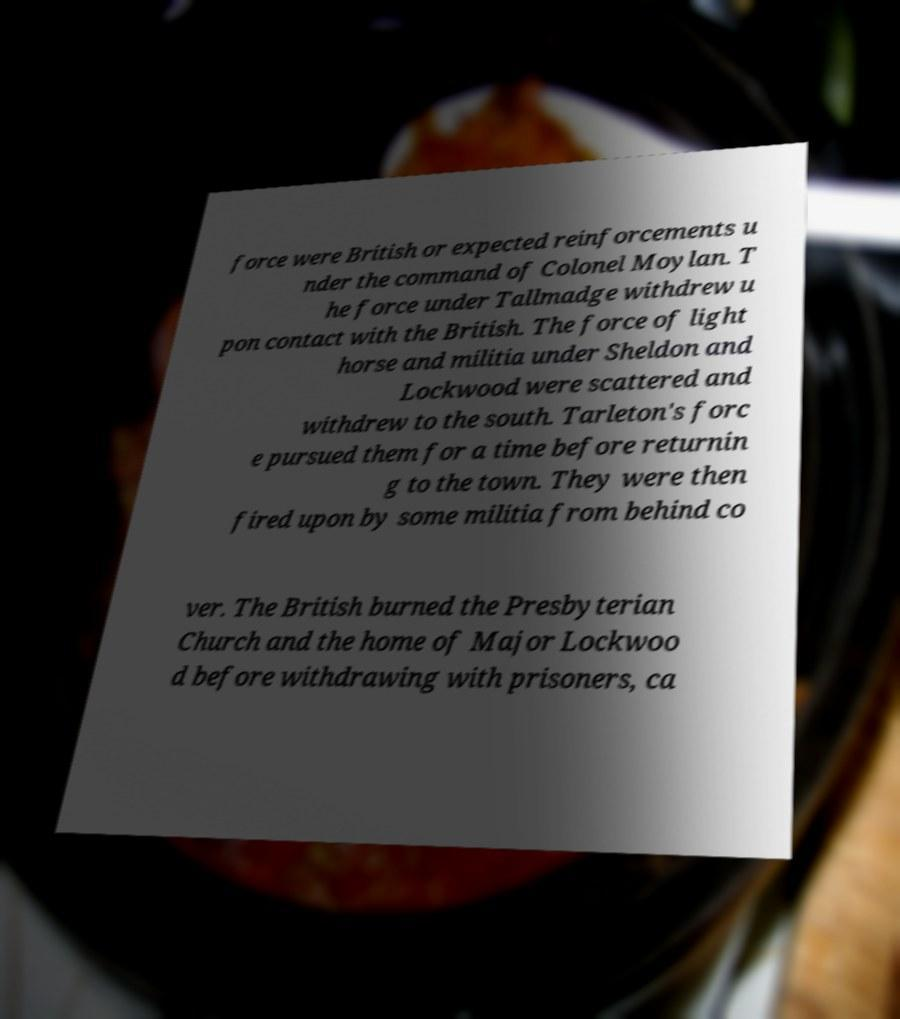Can you read and provide the text displayed in the image?This photo seems to have some interesting text. Can you extract and type it out for me? force were British or expected reinforcements u nder the command of Colonel Moylan. T he force under Tallmadge withdrew u pon contact with the British. The force of light horse and militia under Sheldon and Lockwood were scattered and withdrew to the south. Tarleton's forc e pursued them for a time before returnin g to the town. They were then fired upon by some militia from behind co ver. The British burned the Presbyterian Church and the home of Major Lockwoo d before withdrawing with prisoners, ca 